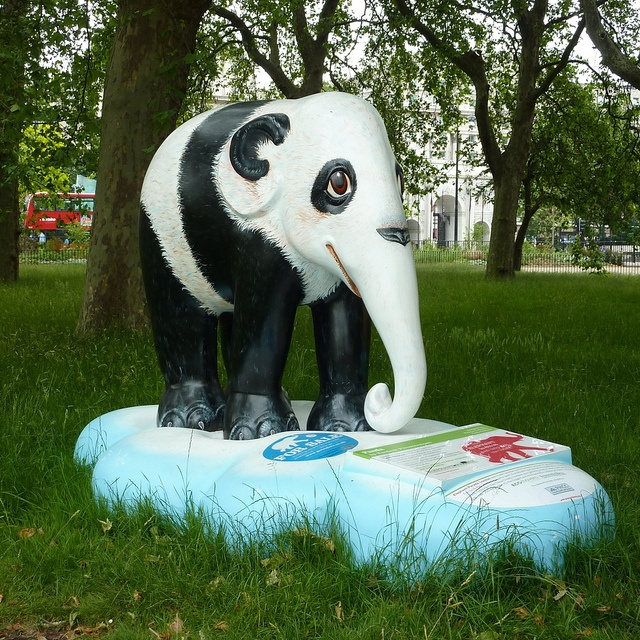Describe the objects in this image and their specific colors. I can see bus in darkgreen, brown, and black tones in this image. 